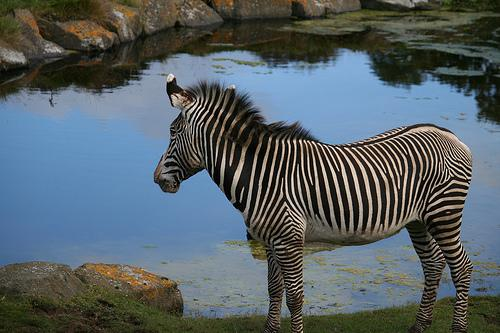Question: what kind of animal is shown?
Choices:
A. Elephant.
B. Lion.
C. Zebra.
D. Crocodile.
Answer with the letter. Answer: C Question: where is the zebra standing?
Choices:
A. Near a tree.
B. Next to water.
C. In tall grass.
D. Near bushes.
Answer with the letter. Answer: B Question: how will the zebra reach the water?
Choices:
A. By walking.
B. By climbing over the rocks.
C. By descending the hill.
D. By running.
Answer with the letter. Answer: A Question: what is on top of the water?
Choices:
A. Birds.
B. Fish.
C. Pond scum.
D. People.
Answer with the letter. Answer: C Question: when is this photo taken?
Choices:
A. Early afternoon.
B. At sunrise.
C. At night.
D. During the daytime.
Answer with the letter. Answer: D 